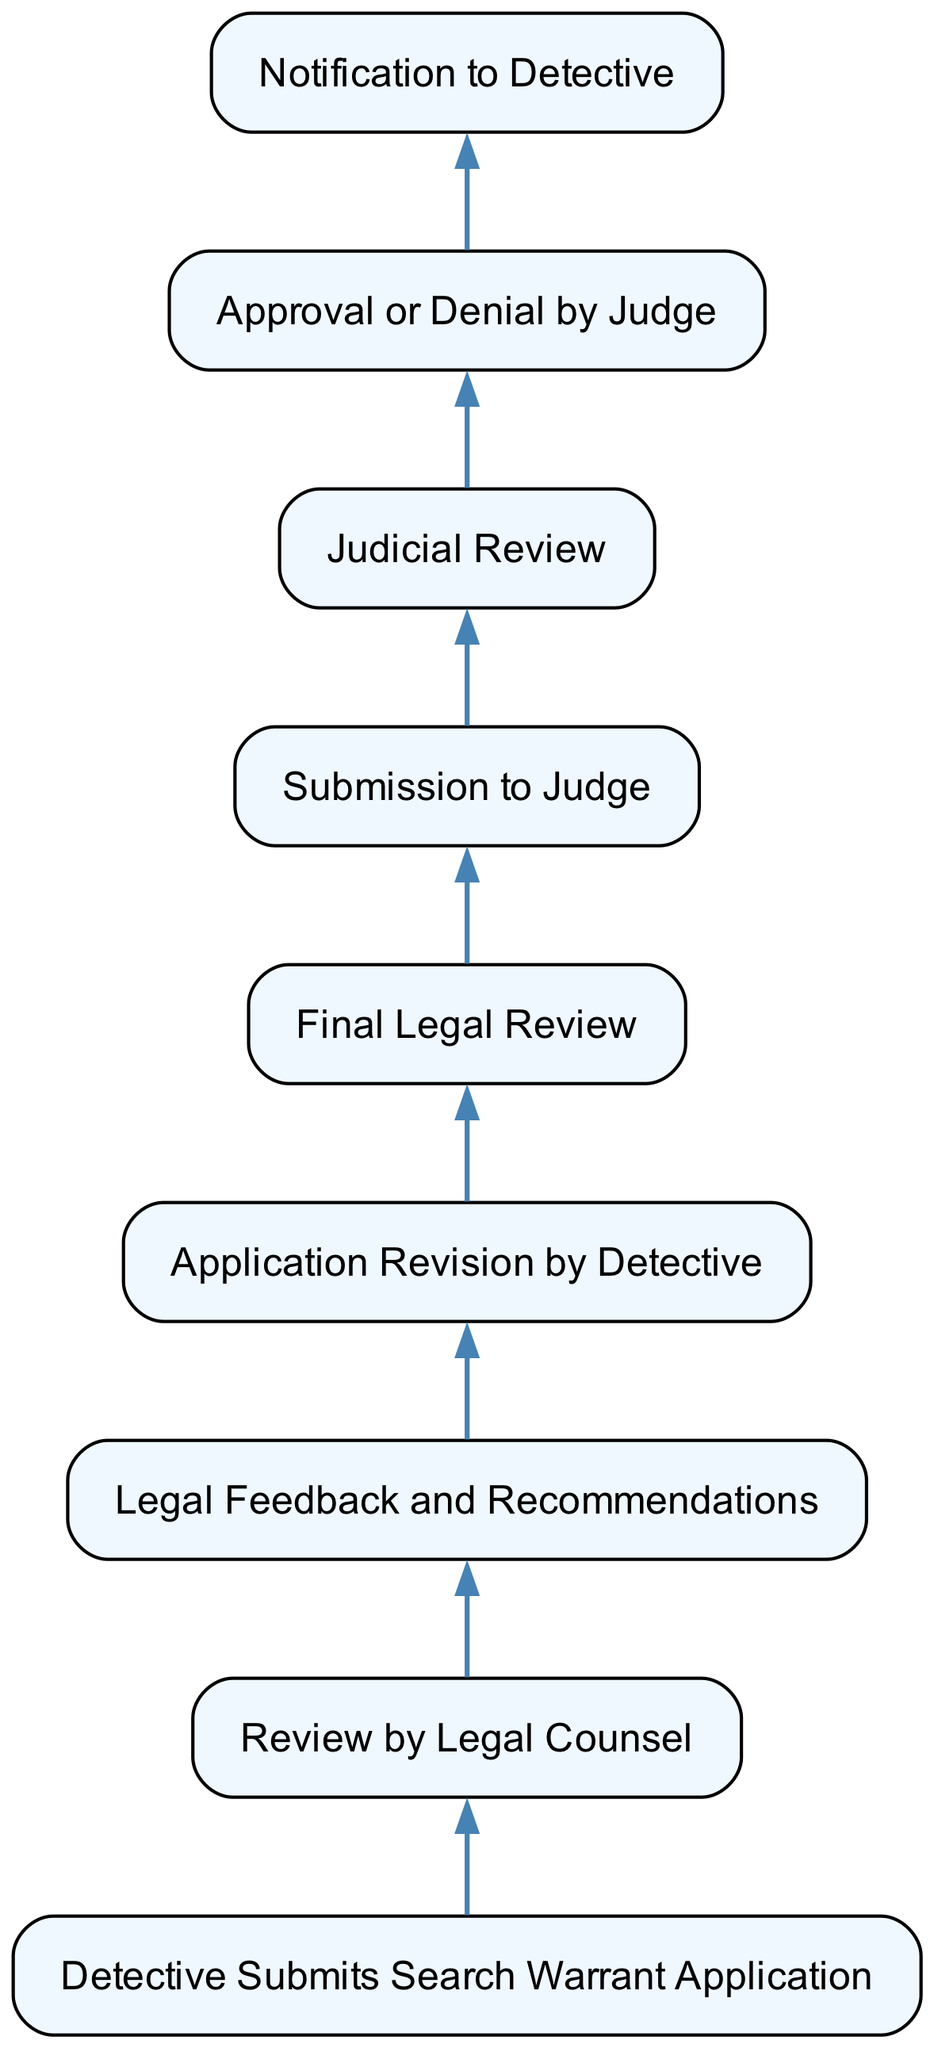What is the first step in the process? The first step in the process is indicated by the bottom node in the diagram, identifying the starting point. The first node states "Detective Submits Search Warrant Application."
Answer: Detective Submits Search Warrant Application How many total nodes are in the diagram? To find the total number of nodes, we can simply count all the elements listed in the diagram. There are nine distinct steps or nodes involved in the process.
Answer: 9 What action follows the "Legal Feedback and Recommendations"? This node connects to the next one where the detective acts on the feedback. The arrow indicates that after receiving feedback, the next step is "Application Revision by Detective."
Answer: Application Revision by Detective What is the role of the judge in the process? The judge has a specific function in the diagram, indicated by the nodes connected to them. They perform the "Judicial Review" and then may provide either "Approval or Denial by Judge."
Answer: Approve or Deny What happens after the "Final Legal Review"? Following the "Final Legal Review," the application transitions to the next step where it is submitted for judgment. The next node in the flow is "Submission to Judge."
Answer: Submission to Judge Which element provides feedback to the detective? Reviewing the arrows and connections in the diagram reveals that the feedback is provided during the "Legal Feedback and Recommendations" step. This step directly informs the detective’s next actions.
Answer: Legal Feedback and Recommendations What is the final outcome of the process? The final result of the process happens after the judge reviews the submission and makes a decision—this is captured in the "Approval or Denial by Judge" node, making it clear the outcome is dependent on this step.
Answer: Approval or Denial by Judge How does the detective update the application? The detective revises the application based on the suggestions and feedback that come from the legal counsel. This is represented in the "Application Revision by Detective" step in the diagram.
Answer: Application Revision by Detective In what phase does the detective receive the judge's decision? Towards the end, after the judge has made a decision regarding the warrant, the "Notification to Detective" step reflects when the detective is informed about the judge's ruling.
Answer: Notification to Detective 